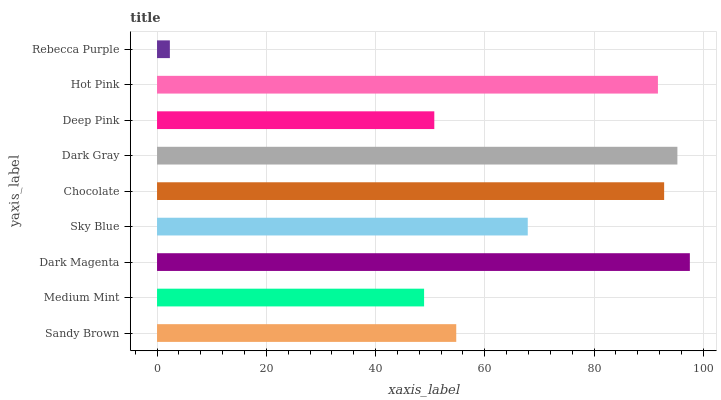Is Rebecca Purple the minimum?
Answer yes or no. Yes. Is Dark Magenta the maximum?
Answer yes or no. Yes. Is Medium Mint the minimum?
Answer yes or no. No. Is Medium Mint the maximum?
Answer yes or no. No. Is Sandy Brown greater than Medium Mint?
Answer yes or no. Yes. Is Medium Mint less than Sandy Brown?
Answer yes or no. Yes. Is Medium Mint greater than Sandy Brown?
Answer yes or no. No. Is Sandy Brown less than Medium Mint?
Answer yes or no. No. Is Sky Blue the high median?
Answer yes or no. Yes. Is Sky Blue the low median?
Answer yes or no. Yes. Is Sandy Brown the high median?
Answer yes or no. No. Is Rebecca Purple the low median?
Answer yes or no. No. 